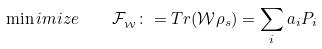<formula> <loc_0><loc_0><loc_500><loc_500>\min i m i z e \quad \mathcal { F } _ { _ { \mathcal { W } } } \colon = T r ( \mathcal { W } \rho _ { s } ) = \sum _ { i } a _ { i } P _ { i }</formula> 